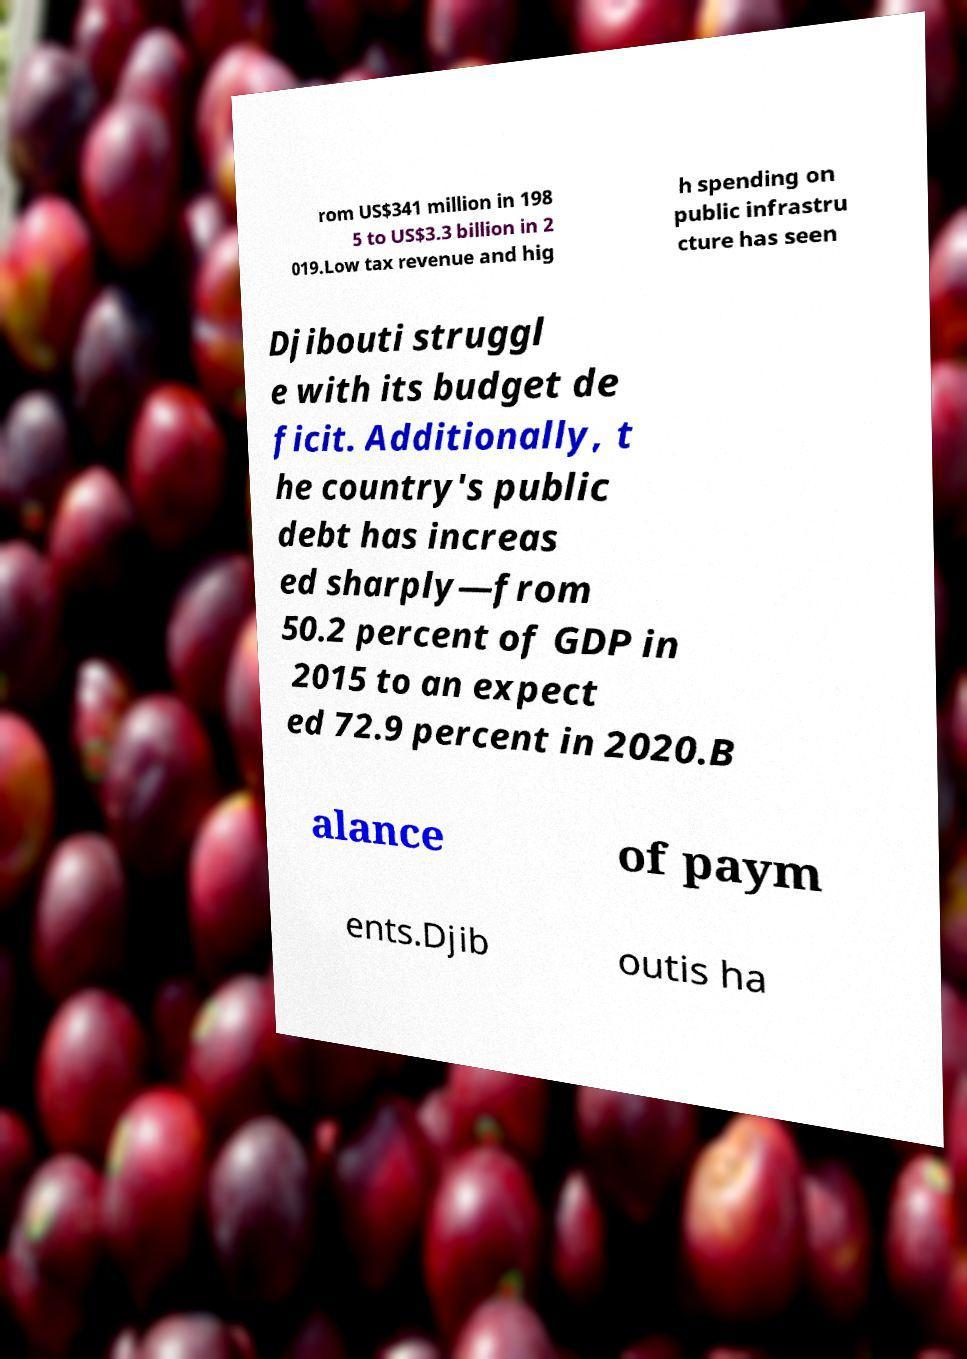For documentation purposes, I need the text within this image transcribed. Could you provide that? rom US$341 million in 198 5 to US$3.3 billion in 2 019.Low tax revenue and hig h spending on public infrastru cture has seen Djibouti struggl e with its budget de ficit. Additionally, t he country's public debt has increas ed sharply—from 50.2 percent of GDP in 2015 to an expect ed 72.9 percent in 2020.B alance of paym ents.Djib outis ha 